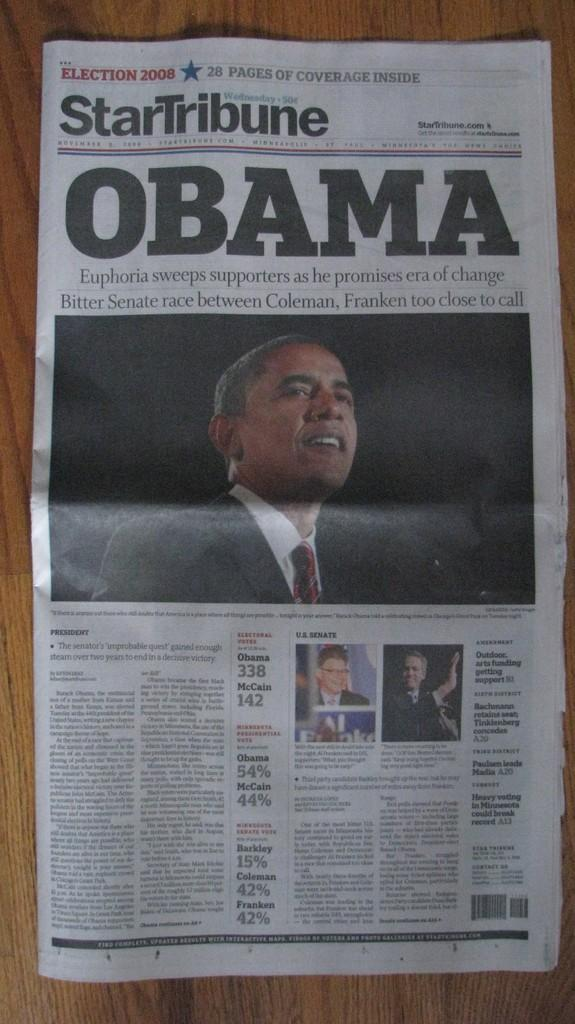What is the main object in the image? There is a newspaper in the image. What can be seen in the pictures on the newspaper? The pictures on the newspaper show people wearing suits and ties. What else is present on the newspaper besides the pictures? There is text on the newspaper. What type of worm can be seen crawling on the lace in the image? There is no worm or lace present in the image; it only features a newspaper with pictures of people wearing suits and ties. 